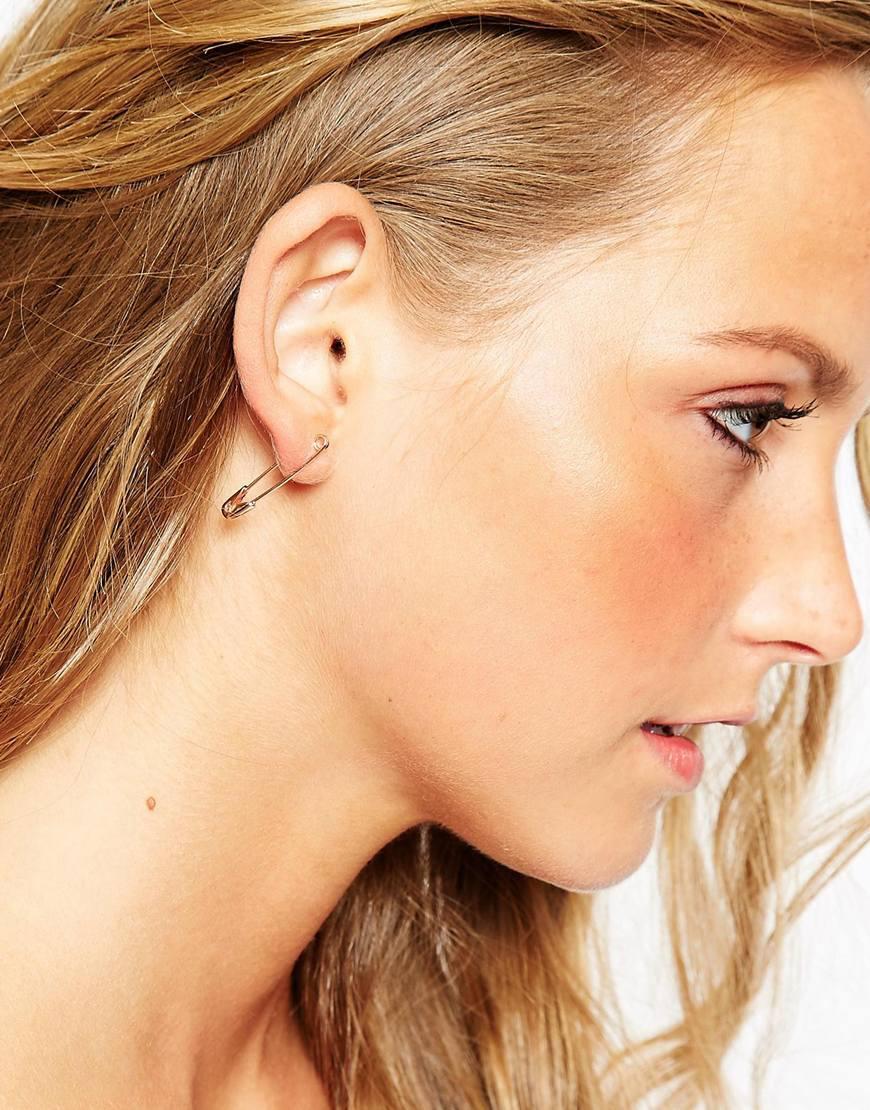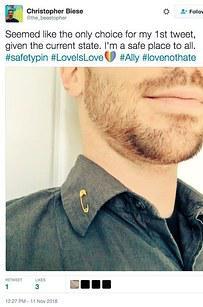The first image is the image on the left, the second image is the image on the right. Examine the images to the left and right. Is the description "One of the images shows a safety pin that is in a location other than a woman's ear." accurate? Answer yes or no. Yes. The first image is the image on the left, the second image is the image on the right. Evaluate the accuracy of this statement regarding the images: "There are two women who are both wearing earrings.". Is it true? Answer yes or no. No. 